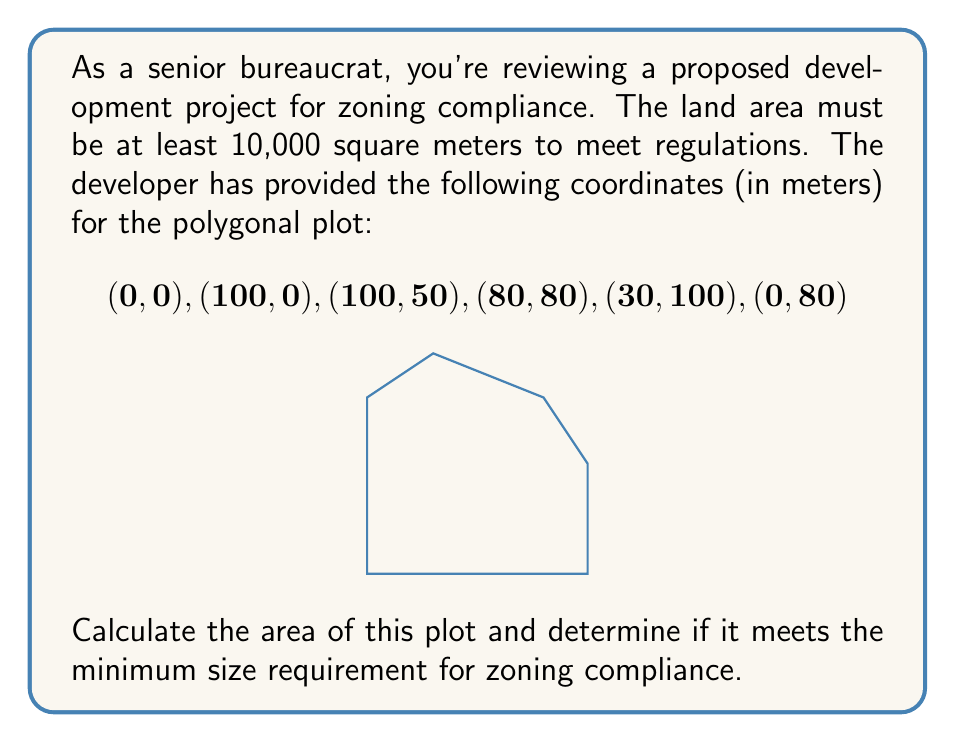Could you help me with this problem? To calculate the area of a polygon given its vertices, we can use the Shoelace formula (also known as the surveyor's formula). The formula is:

$$A = \frac{1}{2}\left|\sum_{i=1}^{n-1} (x_i y_{i+1} + x_n y_1) - \sum_{i=1}^{n-1} (y_i x_{i+1} + y_n x_1)\right|$$

Where $(x_i, y_i)$ are the coordinates of the $i$-th vertex, and $n$ is the number of vertices.

Let's apply this formula to our polygon:

1) First, let's organize our data:
   $(x_1, y_1) = (0, 0)$
   $(x_2, y_2) = (100, 0)$
   $(x_3, y_3) = (100, 50)$
   $(x_4, y_4) = (80, 80)$
   $(x_5, y_5) = (30, 100)$
   $(x_6, y_6) = (0, 80)$

2) Now, let's calculate the first sum:
   $\sum_{i=1}^{n-1} (x_i y_{i+1} + x_n y_1)$
   $= (0 \cdot 0) + (100 \cdot 50) + (100 \cdot 80) + (80 \cdot 100) + (30 \cdot 80) + (0 \cdot 0)$
   $= 0 + 5000 + 8000 + 8000 + 2400 + 0 = 23400$

3) Next, the second sum:
   $\sum_{i=1}^{n-1} (y_i x_{i+1} + y_n x_1)$
   $= (0 \cdot 100) + (0 \cdot 100) + (50 \cdot 80) + (80 \cdot 30) + (100 \cdot 0) + (80 \cdot 0)$
   $= 0 + 0 + 4000 + 2400 + 0 + 0 = 6400$

4) Now we can subtract and take the absolute value:
   $|23400 - 6400| = 17000$

5) Finally, we divide by 2:
   $A = \frac{1}{2} \cdot 17000 = 8500$ square meters

The calculated area is 8,500 square meters, which is less than the required 10,000 square meters for zoning compliance.
Answer: The area of the plot is 8,500 square meters. This does not meet the minimum size requirement of 10,000 square meters for zoning compliance. 